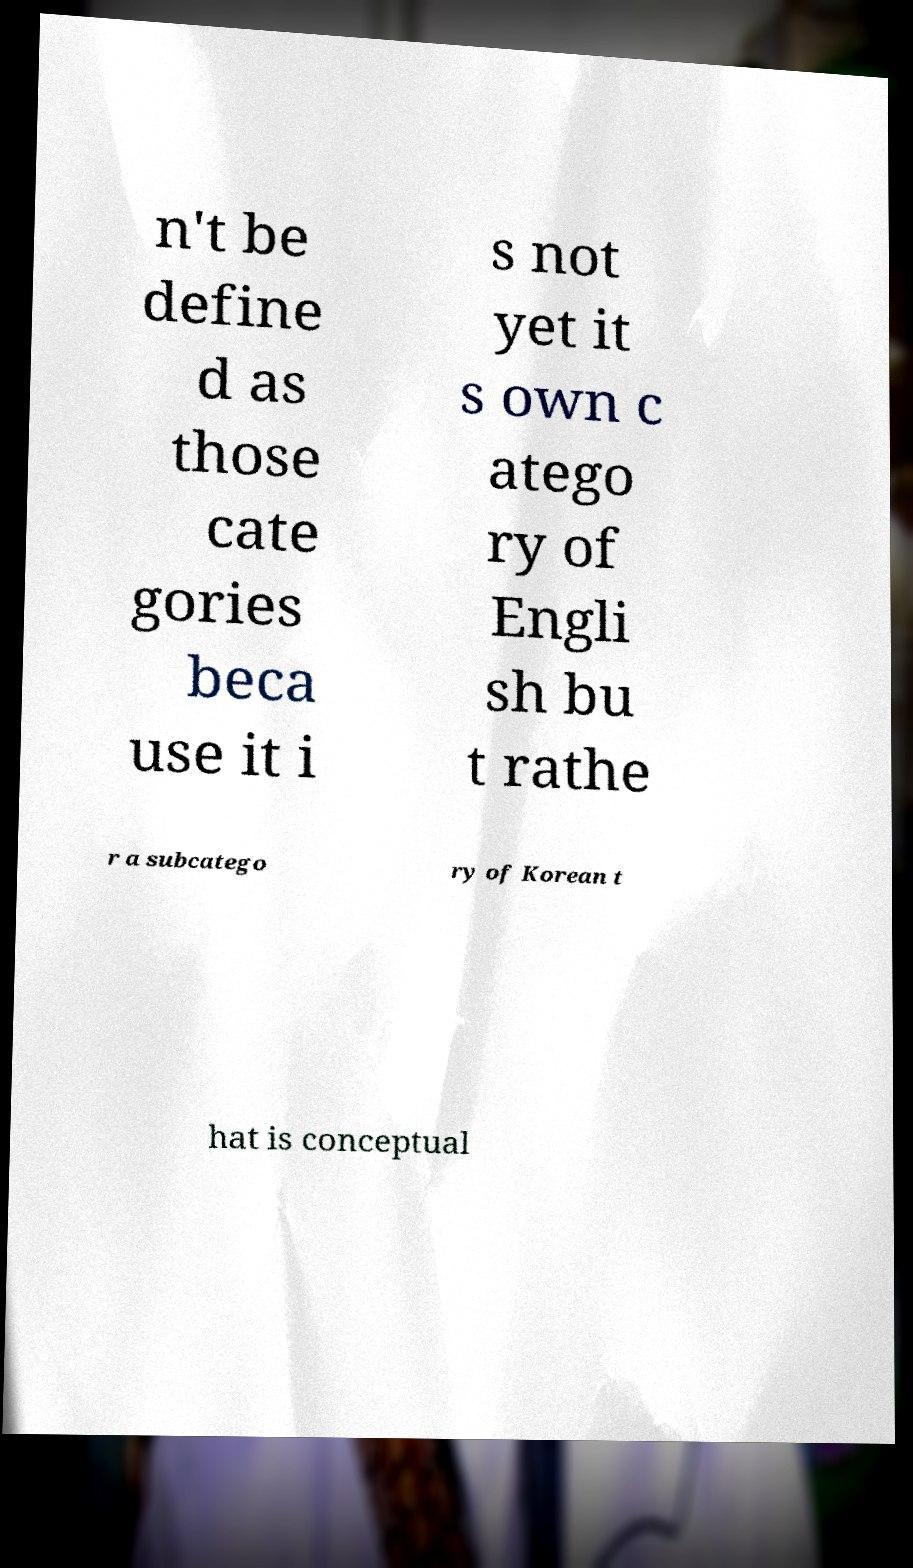Please identify and transcribe the text found in this image. n't be define d as those cate gories beca use it i s not yet it s own c atego ry of Engli sh bu t rathe r a subcatego ry of Korean t hat is conceptual 